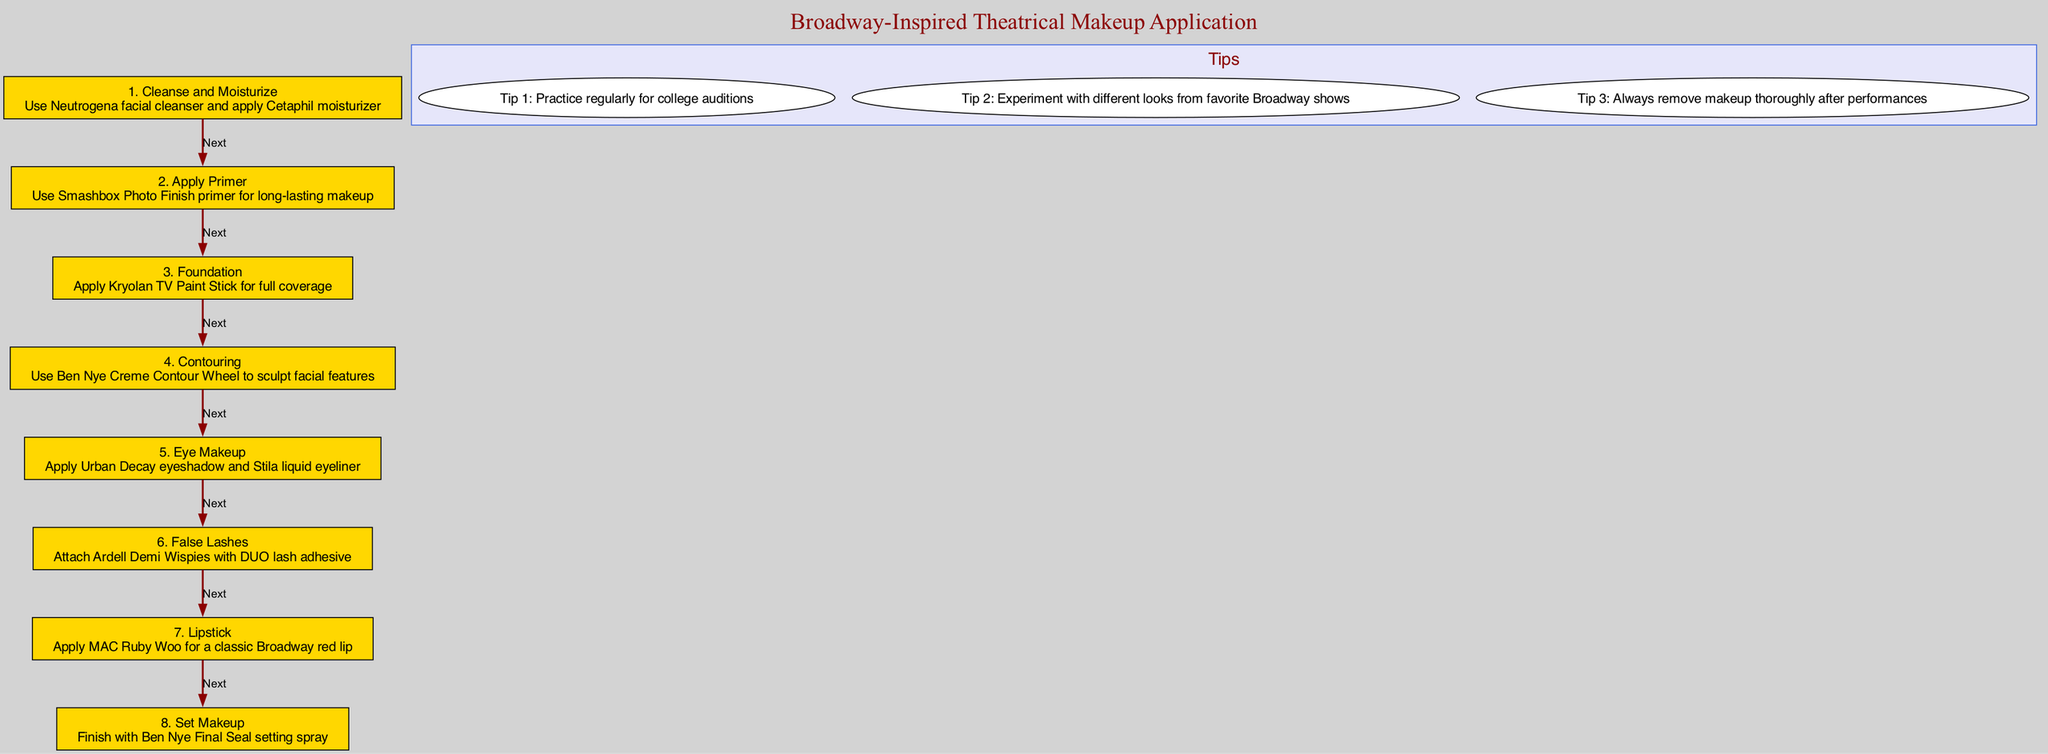What is the first step in the makeup application process? The first step listed in the diagram is "Cleanse and Moisturize". It is the topmost step, which means it is performed before any other steps.
Answer: Cleanse and Moisturize How many makeup application steps are shown in the diagram? The diagram lists 8 steps in total for the makeup application process, which can be counted sequentially from the first step to the last.
Answer: 8 What product is recommended for applying foundation? The description under the "Foundation" step specifies using "Kryolan TV Paint Stick" for full coverage. Therefore, the response is based on the information in that particular step.
Answer: Kryolan TV Paint Stick What is the recommended setting spray in the final step? The last step mentioned in the diagram is "Set Makeup", which recommends using "Ben Nye Final Seal setting spray". This is derived from its specific mention in the step's description.
Answer: Ben Nye Final Seal Which step comes directly after applying eye makeup? According to the flow of the diagram, "False Lashes" is the next step that follows "Eye Makeup". This can be determined by checking the sequence of the steps.
Answer: False Lashes Which tip suggests to remove makeup after performances? The third tip in the 'Tips' cluster emphasizes on this: "Always remove makeup thoroughly after performances". Identifying the tips allows us to find the answer quickly.
Answer: Always remove makeup thoroughly after performances What color is suggested for the lipstick? The “Lipstick” step specifically recommends "MAC Ruby Woo" for a classic Broadway red lip, directly stating the color intended for lip application.
Answer: MAC Ruby Woo What is the function of the primer according to the diagram? The description under the "Apply Primer" step states it is used for "long-lasting makeup", providing the specific purpose of this product in the makeup application.
Answer: Long-lasting makeup In total, how many tips are provided? The diagram outlines 3 tips within the tips cluster, which can be counted as they are presented distinctly.
Answer: 3 